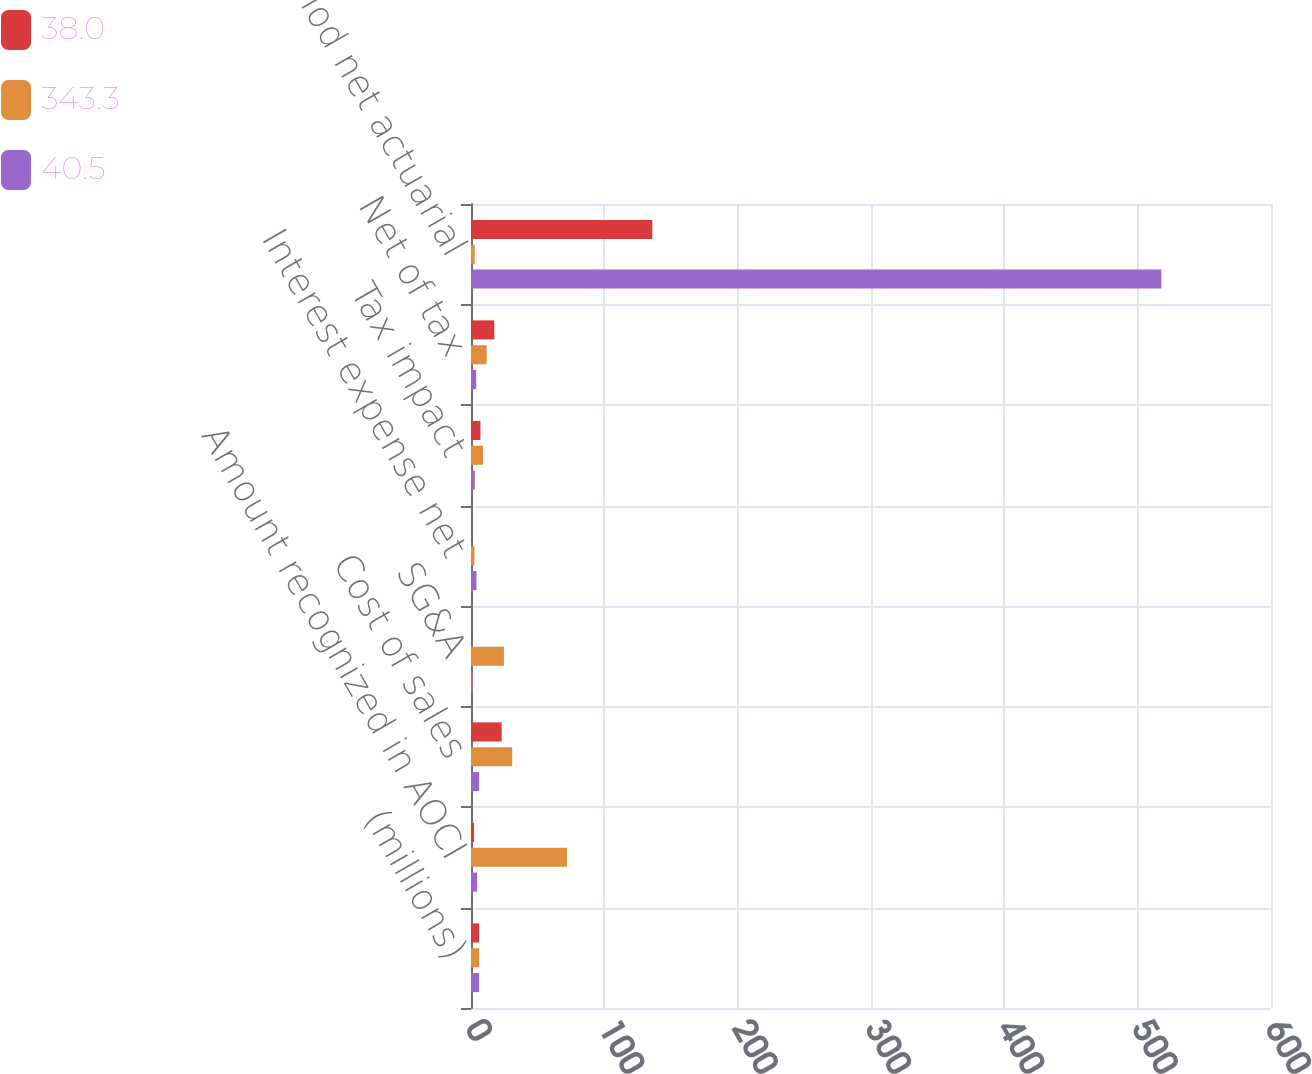<chart> <loc_0><loc_0><loc_500><loc_500><stacked_bar_chart><ecel><fcel>(millions)<fcel>Amount recognized in AOCI<fcel>Cost of sales<fcel>SG&A<fcel>Interest expense net<fcel>Tax impact<fcel>Net of tax<fcel>Current period net actuarial<nl><fcel>38<fcel>6.1<fcel>2.3<fcel>23<fcel>0.1<fcel>0.8<fcel>7.1<fcel>17.5<fcel>136<nl><fcel>343.3<fcel>6.1<fcel>72<fcel>30.9<fcel>24.7<fcel>2.6<fcel>9<fcel>11.7<fcel>2.8<nl><fcel>40.5<fcel>6.1<fcel>4.6<fcel>6.1<fcel>1.5<fcel>4.1<fcel>2.8<fcel>3.9<fcel>517.7<nl></chart> 